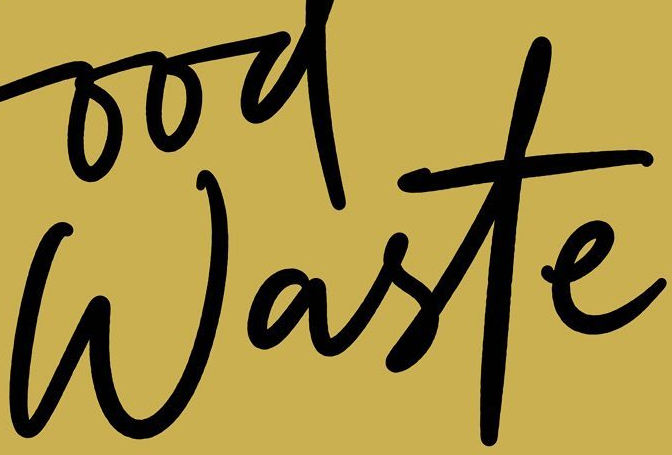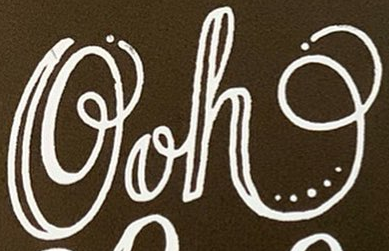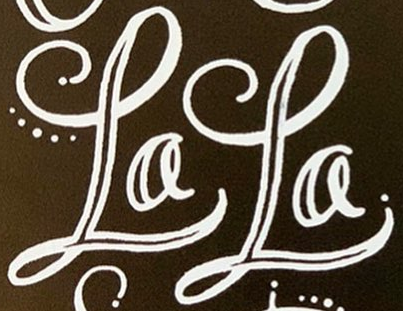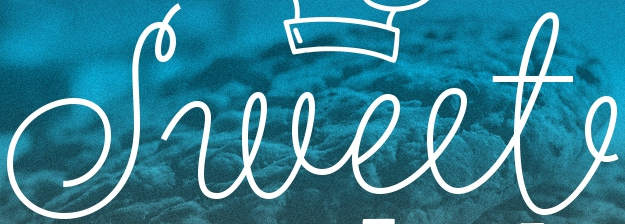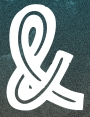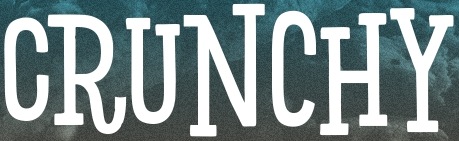Read the text content from these images in order, separated by a semicolon. Waste; Ooh; LaLa; Sweet; &; CRUNCHY 